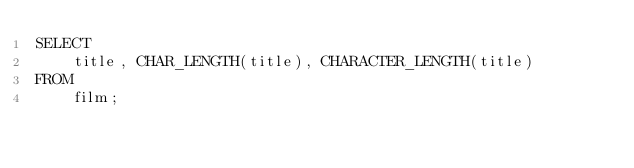Convert code to text. <code><loc_0><loc_0><loc_500><loc_500><_SQL_>SELECT 
    title, CHAR_LENGTH(title), CHARACTER_LENGTH(title)
FROM
    film;</code> 